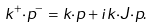Convert formula to latex. <formula><loc_0><loc_0><loc_500><loc_500>k ^ { + } { \cdot } p ^ { - } = k { \cdot } p + i k { \cdot } J { \cdot } p .</formula> 